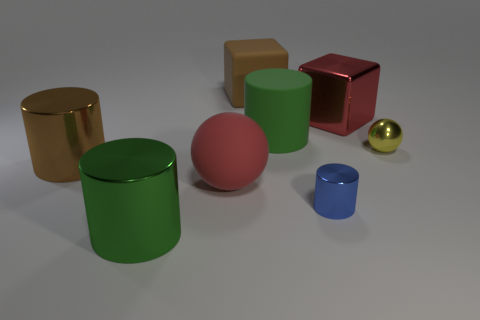What number of big objects are either green spheres or matte cylinders?
Provide a short and direct response. 1. What is the size of the brown thing that is in front of the yellow metallic ball?
Provide a short and direct response. Large. Are there any objects of the same color as the large shiny cube?
Provide a short and direct response. Yes. Do the big ball and the shiny block have the same color?
Offer a very short reply. Yes. There is a metal object that is the same color as the large rubber cube; what shape is it?
Ensure brevity in your answer.  Cylinder. There is a big shiny thing that is on the left side of the green metal object; how many spheres are behind it?
Offer a very short reply. 1. How many green cylinders have the same material as the red block?
Your answer should be compact. 1. There is a green shiny cylinder; are there any objects right of it?
Your answer should be very brief. Yes. What color is the matte cylinder that is the same size as the red matte sphere?
Offer a terse response. Green. How many objects are either large red things in front of the large red metallic block or large green metal cylinders?
Your answer should be very brief. 2. 